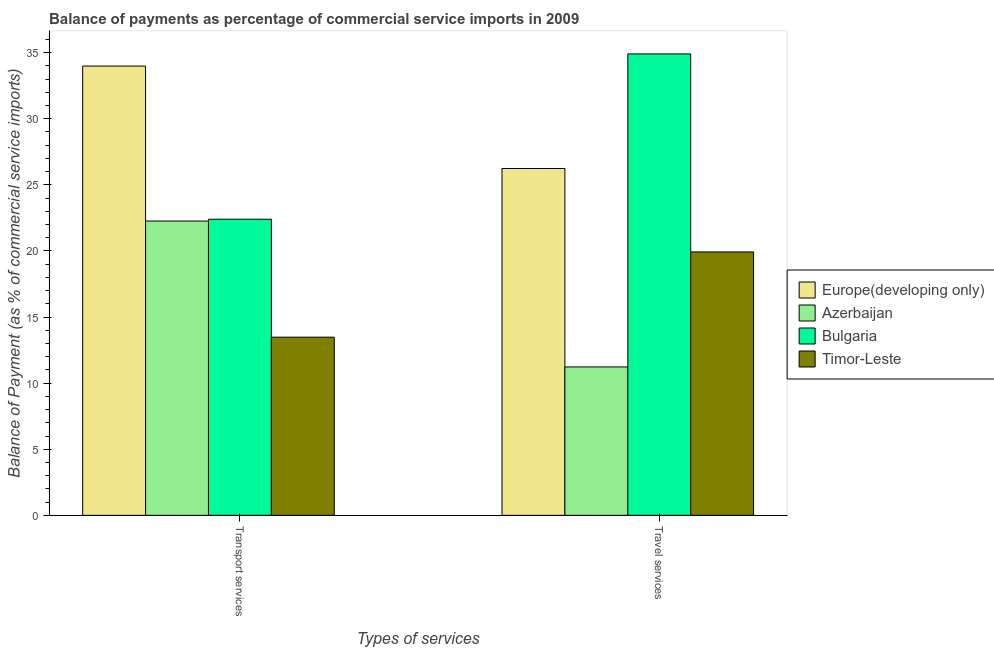How many different coloured bars are there?
Keep it short and to the point. 4. How many groups of bars are there?
Keep it short and to the point. 2. How many bars are there on the 1st tick from the left?
Ensure brevity in your answer.  4. What is the label of the 1st group of bars from the left?
Your answer should be very brief. Transport services. What is the balance of payments of transport services in Europe(developing only)?
Ensure brevity in your answer.  33.99. Across all countries, what is the maximum balance of payments of travel services?
Ensure brevity in your answer.  34.91. Across all countries, what is the minimum balance of payments of transport services?
Your answer should be compact. 13.48. In which country was the balance of payments of transport services minimum?
Make the answer very short. Timor-Leste. What is the total balance of payments of travel services in the graph?
Your answer should be compact. 92.3. What is the difference between the balance of payments of travel services in Bulgaria and that in Europe(developing only)?
Keep it short and to the point. 8.67. What is the difference between the balance of payments of transport services in Europe(developing only) and the balance of payments of travel services in Bulgaria?
Provide a succinct answer. -0.92. What is the average balance of payments of travel services per country?
Your answer should be compact. 23.07. What is the difference between the balance of payments of travel services and balance of payments of transport services in Timor-Leste?
Make the answer very short. 6.45. In how many countries, is the balance of payments of transport services greater than 1 %?
Give a very brief answer. 4. What is the ratio of the balance of payments of transport services in Timor-Leste to that in Europe(developing only)?
Offer a very short reply. 0.4. Is the balance of payments of transport services in Timor-Leste less than that in Azerbaijan?
Your answer should be very brief. Yes. In how many countries, is the balance of payments of transport services greater than the average balance of payments of transport services taken over all countries?
Your response must be concise. 1. What does the 4th bar from the left in Transport services represents?
Keep it short and to the point. Timor-Leste. What does the 3rd bar from the right in Travel services represents?
Provide a short and direct response. Azerbaijan. Does the graph contain any zero values?
Make the answer very short. No. Where does the legend appear in the graph?
Make the answer very short. Center right. What is the title of the graph?
Your response must be concise. Balance of payments as percentage of commercial service imports in 2009. Does "Korea (Democratic)" appear as one of the legend labels in the graph?
Provide a succinct answer. No. What is the label or title of the X-axis?
Your answer should be very brief. Types of services. What is the label or title of the Y-axis?
Your answer should be compact. Balance of Payment (as % of commercial service imports). What is the Balance of Payment (as % of commercial service imports) in Europe(developing only) in Transport services?
Your response must be concise. 33.99. What is the Balance of Payment (as % of commercial service imports) in Azerbaijan in Transport services?
Provide a short and direct response. 22.26. What is the Balance of Payment (as % of commercial service imports) in Bulgaria in Transport services?
Make the answer very short. 22.4. What is the Balance of Payment (as % of commercial service imports) in Timor-Leste in Transport services?
Your answer should be very brief. 13.48. What is the Balance of Payment (as % of commercial service imports) of Europe(developing only) in Travel services?
Your response must be concise. 26.24. What is the Balance of Payment (as % of commercial service imports) in Azerbaijan in Travel services?
Provide a succinct answer. 11.23. What is the Balance of Payment (as % of commercial service imports) in Bulgaria in Travel services?
Your response must be concise. 34.91. What is the Balance of Payment (as % of commercial service imports) of Timor-Leste in Travel services?
Your response must be concise. 19.93. Across all Types of services, what is the maximum Balance of Payment (as % of commercial service imports) in Europe(developing only)?
Your answer should be very brief. 33.99. Across all Types of services, what is the maximum Balance of Payment (as % of commercial service imports) of Azerbaijan?
Provide a short and direct response. 22.26. Across all Types of services, what is the maximum Balance of Payment (as % of commercial service imports) of Bulgaria?
Keep it short and to the point. 34.91. Across all Types of services, what is the maximum Balance of Payment (as % of commercial service imports) in Timor-Leste?
Make the answer very short. 19.93. Across all Types of services, what is the minimum Balance of Payment (as % of commercial service imports) of Europe(developing only)?
Your answer should be compact. 26.24. Across all Types of services, what is the minimum Balance of Payment (as % of commercial service imports) of Azerbaijan?
Give a very brief answer. 11.23. Across all Types of services, what is the minimum Balance of Payment (as % of commercial service imports) of Bulgaria?
Keep it short and to the point. 22.4. Across all Types of services, what is the minimum Balance of Payment (as % of commercial service imports) of Timor-Leste?
Offer a terse response. 13.48. What is the total Balance of Payment (as % of commercial service imports) of Europe(developing only) in the graph?
Your answer should be compact. 60.22. What is the total Balance of Payment (as % of commercial service imports) of Azerbaijan in the graph?
Your response must be concise. 33.49. What is the total Balance of Payment (as % of commercial service imports) in Bulgaria in the graph?
Provide a short and direct response. 57.31. What is the total Balance of Payment (as % of commercial service imports) of Timor-Leste in the graph?
Provide a short and direct response. 33.41. What is the difference between the Balance of Payment (as % of commercial service imports) in Europe(developing only) in Transport services and that in Travel services?
Give a very brief answer. 7.75. What is the difference between the Balance of Payment (as % of commercial service imports) of Azerbaijan in Transport services and that in Travel services?
Your response must be concise. 11.04. What is the difference between the Balance of Payment (as % of commercial service imports) of Bulgaria in Transport services and that in Travel services?
Provide a short and direct response. -12.51. What is the difference between the Balance of Payment (as % of commercial service imports) in Timor-Leste in Transport services and that in Travel services?
Your answer should be very brief. -6.45. What is the difference between the Balance of Payment (as % of commercial service imports) in Europe(developing only) in Transport services and the Balance of Payment (as % of commercial service imports) in Azerbaijan in Travel services?
Make the answer very short. 22.76. What is the difference between the Balance of Payment (as % of commercial service imports) of Europe(developing only) in Transport services and the Balance of Payment (as % of commercial service imports) of Bulgaria in Travel services?
Offer a very short reply. -0.92. What is the difference between the Balance of Payment (as % of commercial service imports) in Europe(developing only) in Transport services and the Balance of Payment (as % of commercial service imports) in Timor-Leste in Travel services?
Keep it short and to the point. 14.06. What is the difference between the Balance of Payment (as % of commercial service imports) in Azerbaijan in Transport services and the Balance of Payment (as % of commercial service imports) in Bulgaria in Travel services?
Offer a terse response. -12.64. What is the difference between the Balance of Payment (as % of commercial service imports) of Azerbaijan in Transport services and the Balance of Payment (as % of commercial service imports) of Timor-Leste in Travel services?
Give a very brief answer. 2.34. What is the difference between the Balance of Payment (as % of commercial service imports) in Bulgaria in Transport services and the Balance of Payment (as % of commercial service imports) in Timor-Leste in Travel services?
Give a very brief answer. 2.47. What is the average Balance of Payment (as % of commercial service imports) in Europe(developing only) per Types of services?
Give a very brief answer. 30.11. What is the average Balance of Payment (as % of commercial service imports) in Azerbaijan per Types of services?
Make the answer very short. 16.74. What is the average Balance of Payment (as % of commercial service imports) of Bulgaria per Types of services?
Your response must be concise. 28.65. What is the average Balance of Payment (as % of commercial service imports) in Timor-Leste per Types of services?
Make the answer very short. 16.7. What is the difference between the Balance of Payment (as % of commercial service imports) of Europe(developing only) and Balance of Payment (as % of commercial service imports) of Azerbaijan in Transport services?
Make the answer very short. 11.72. What is the difference between the Balance of Payment (as % of commercial service imports) in Europe(developing only) and Balance of Payment (as % of commercial service imports) in Bulgaria in Transport services?
Your answer should be compact. 11.59. What is the difference between the Balance of Payment (as % of commercial service imports) in Europe(developing only) and Balance of Payment (as % of commercial service imports) in Timor-Leste in Transport services?
Your response must be concise. 20.51. What is the difference between the Balance of Payment (as % of commercial service imports) of Azerbaijan and Balance of Payment (as % of commercial service imports) of Bulgaria in Transport services?
Provide a succinct answer. -0.14. What is the difference between the Balance of Payment (as % of commercial service imports) in Azerbaijan and Balance of Payment (as % of commercial service imports) in Timor-Leste in Transport services?
Provide a short and direct response. 8.78. What is the difference between the Balance of Payment (as % of commercial service imports) in Bulgaria and Balance of Payment (as % of commercial service imports) in Timor-Leste in Transport services?
Your answer should be compact. 8.92. What is the difference between the Balance of Payment (as % of commercial service imports) in Europe(developing only) and Balance of Payment (as % of commercial service imports) in Azerbaijan in Travel services?
Keep it short and to the point. 15.01. What is the difference between the Balance of Payment (as % of commercial service imports) in Europe(developing only) and Balance of Payment (as % of commercial service imports) in Bulgaria in Travel services?
Offer a very short reply. -8.67. What is the difference between the Balance of Payment (as % of commercial service imports) in Europe(developing only) and Balance of Payment (as % of commercial service imports) in Timor-Leste in Travel services?
Provide a succinct answer. 6.31. What is the difference between the Balance of Payment (as % of commercial service imports) in Azerbaijan and Balance of Payment (as % of commercial service imports) in Bulgaria in Travel services?
Provide a short and direct response. -23.68. What is the difference between the Balance of Payment (as % of commercial service imports) of Azerbaijan and Balance of Payment (as % of commercial service imports) of Timor-Leste in Travel services?
Give a very brief answer. -8.7. What is the difference between the Balance of Payment (as % of commercial service imports) of Bulgaria and Balance of Payment (as % of commercial service imports) of Timor-Leste in Travel services?
Provide a succinct answer. 14.98. What is the ratio of the Balance of Payment (as % of commercial service imports) in Europe(developing only) in Transport services to that in Travel services?
Your response must be concise. 1.3. What is the ratio of the Balance of Payment (as % of commercial service imports) of Azerbaijan in Transport services to that in Travel services?
Make the answer very short. 1.98. What is the ratio of the Balance of Payment (as % of commercial service imports) of Bulgaria in Transport services to that in Travel services?
Provide a short and direct response. 0.64. What is the ratio of the Balance of Payment (as % of commercial service imports) of Timor-Leste in Transport services to that in Travel services?
Provide a succinct answer. 0.68. What is the difference between the highest and the second highest Balance of Payment (as % of commercial service imports) in Europe(developing only)?
Your response must be concise. 7.75. What is the difference between the highest and the second highest Balance of Payment (as % of commercial service imports) of Azerbaijan?
Offer a very short reply. 11.04. What is the difference between the highest and the second highest Balance of Payment (as % of commercial service imports) of Bulgaria?
Provide a short and direct response. 12.51. What is the difference between the highest and the second highest Balance of Payment (as % of commercial service imports) in Timor-Leste?
Provide a short and direct response. 6.45. What is the difference between the highest and the lowest Balance of Payment (as % of commercial service imports) in Europe(developing only)?
Your response must be concise. 7.75. What is the difference between the highest and the lowest Balance of Payment (as % of commercial service imports) of Azerbaijan?
Offer a very short reply. 11.04. What is the difference between the highest and the lowest Balance of Payment (as % of commercial service imports) of Bulgaria?
Your answer should be very brief. 12.51. What is the difference between the highest and the lowest Balance of Payment (as % of commercial service imports) in Timor-Leste?
Your answer should be very brief. 6.45. 